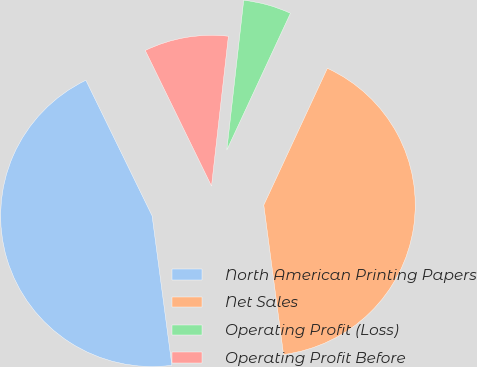Convert chart. <chart><loc_0><loc_0><loc_500><loc_500><pie_chart><fcel>North American Printing Papers<fcel>Net Sales<fcel>Operating Profit (Loss)<fcel>Operating Profit Before<nl><fcel>44.88%<fcel>41.02%<fcel>5.12%<fcel>8.98%<nl></chart> 